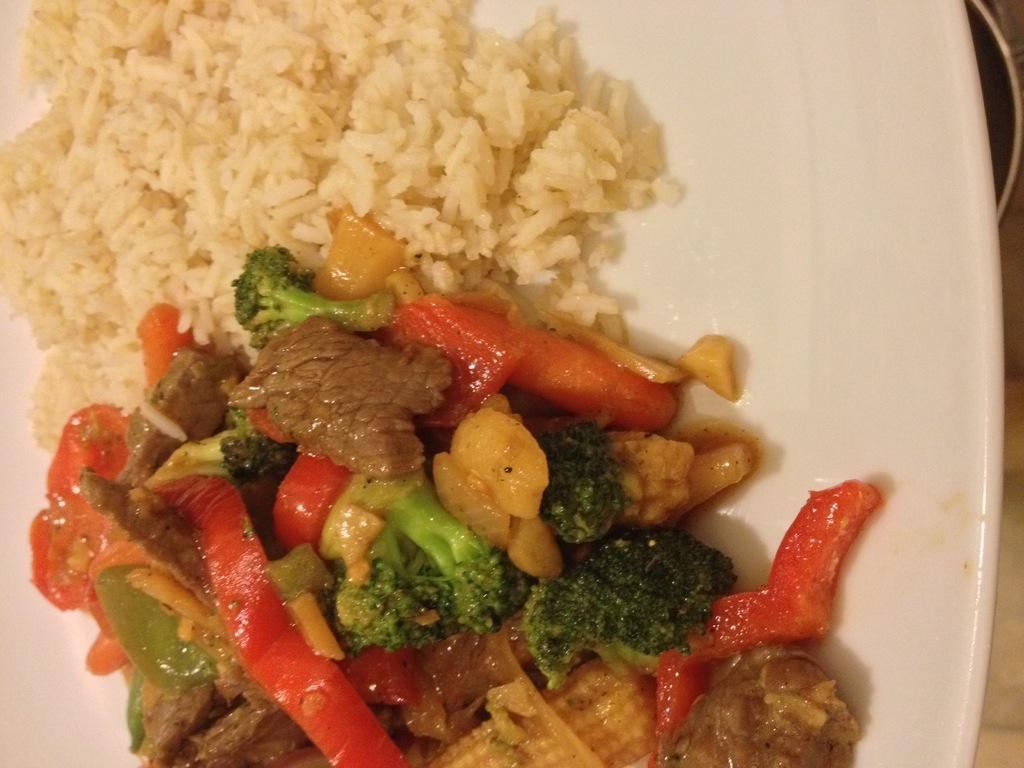What is on the plate that is visible in the image? There is food on a plate in the image. What other dish can be seen in the image? There is a bowl at the bottom of the image. What piece of furniture is present in the image? There is a table in the image. What type of apple is being used as a paperweight on the table in the image? There is no apple present in the image, nor is there any indication of a paperweight. 